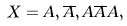Convert formula to latex. <formula><loc_0><loc_0><loc_500><loc_500>X = A , \overline { A } , A \overline { A } A ,</formula> 